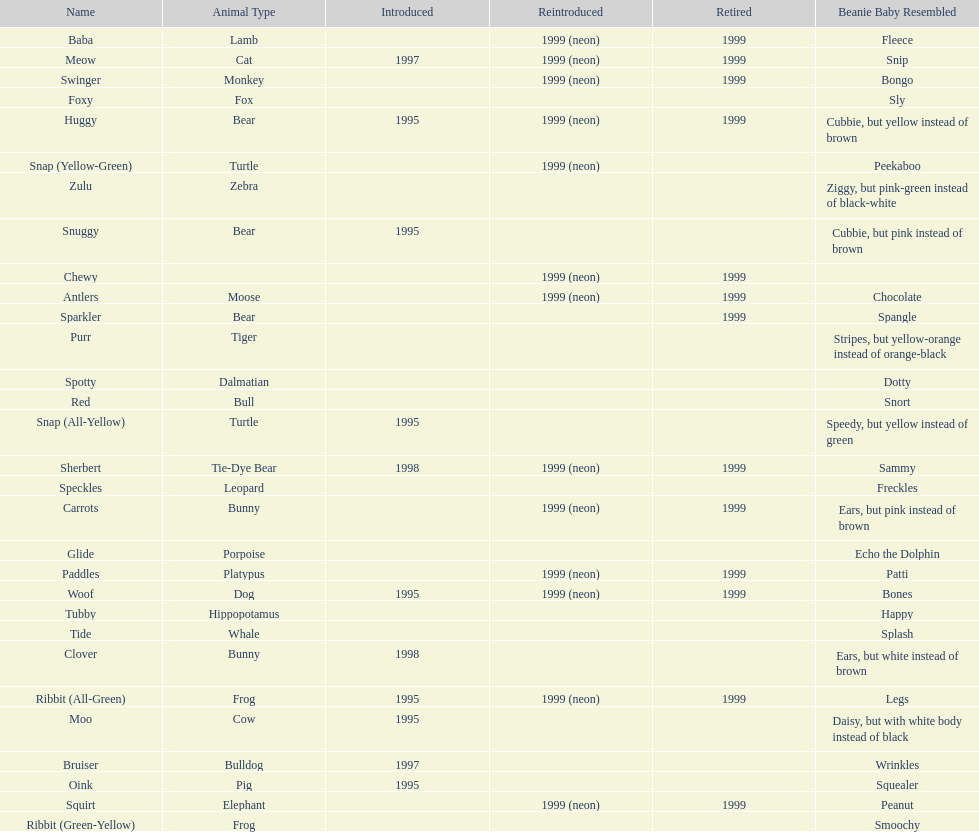What is the number of frog pillow pals? 2. 